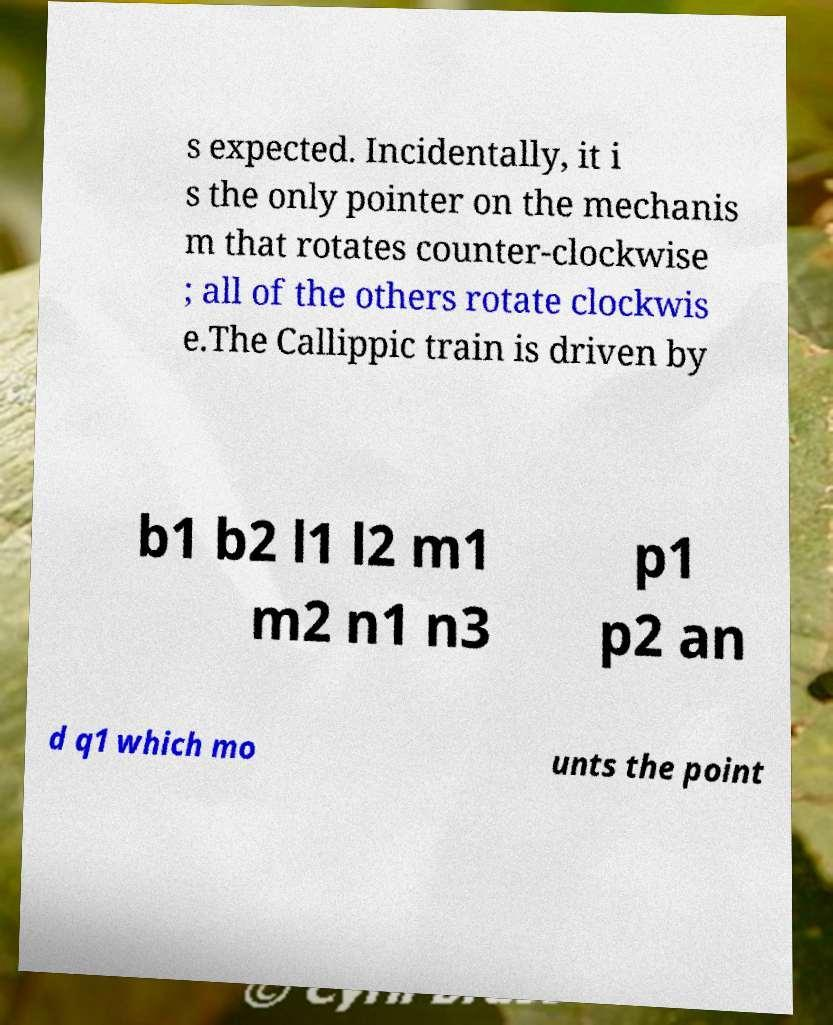Please identify and transcribe the text found in this image. s expected. Incidentally, it i s the only pointer on the mechanis m that rotates counter-clockwise ; all of the others rotate clockwis e.The Callippic train is driven by b1 b2 l1 l2 m1 m2 n1 n3 p1 p2 an d q1 which mo unts the point 